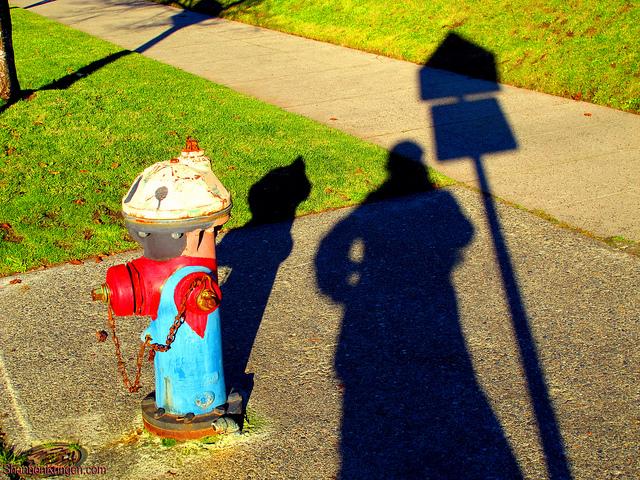Is there a shadow of a person?
Answer briefly. Yes. Is the fire hydrant decorated as a person?
Be succinct. Yes. What colors are the fire hydrant?
Keep it brief. Red and blue. 